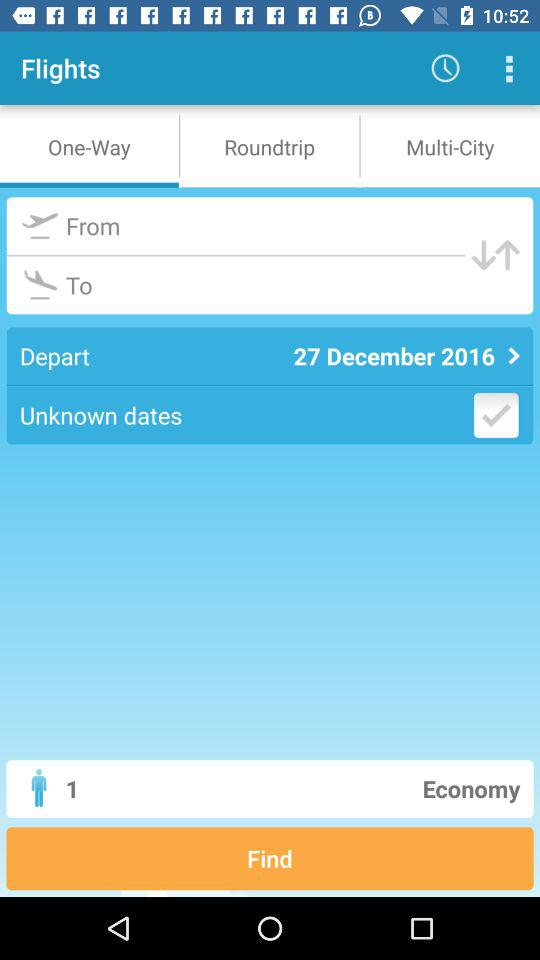What is the departure date? The departure date is December 27, 2016. 